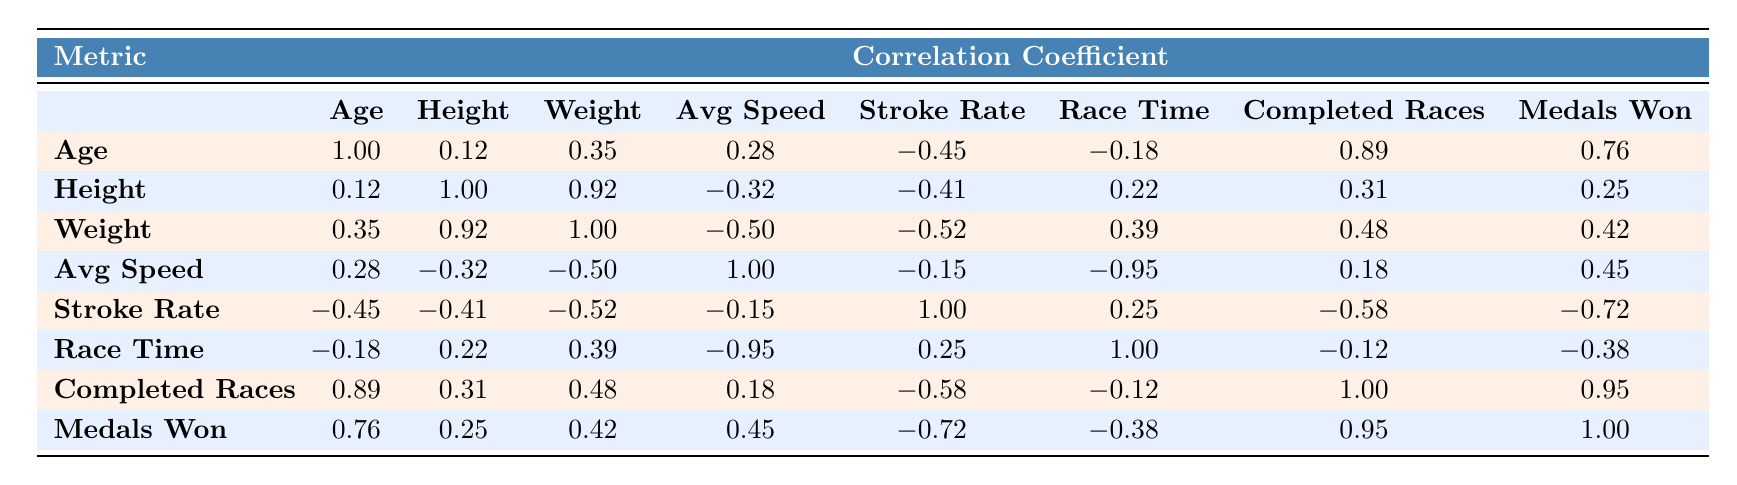What is the correlation coefficient between age and race time? According to the table, the correlation coefficient between age and race time is -0.18. This indicates a slight negative correlation, meaning as age increases, race time slightly tends to decrease.
Answer: -0.18 Which athlete has the highest average speed? By examining the Avg Speed column, Jane Smith has the highest average speed of 6.5 m/s.
Answer: 6.5 m/s Is there a strong correlation between completed races and medals won? The table shows a correlation coefficient of 0.95 between completed races and medals won. This indicates a very strong positive correlation, meaning as the number of completed races increases, the number of medals won also tends to increase significantly.
Answer: Yes What is the average stroke rate of the athletes listed? To find the average stroke rate, sum the stroke rates (32 + 30 + 34 + 31 + 33 = 160) and divide by the number of athletes (5). Thus, the average stroke rate is 160 / 5 = 32.
Answer: 32 If we compare the height of Michael Brown and Emily Wilson, who is taller and by how many centimeters? Michael Brown's height is 190 cm while Emily Wilson's height is 175 cm. The difference in their heights is 190 - 175 = 15 cm, indicating Michael is taller by 15 cm.
Answer: 15 cm What is the relationship between weight and average speed? The correlation coefficient between weight and average speed is -0.50, indicating a moderate negative relationship; as weight increases, the average speed tends to decrease.
Answer: Moderate negative correlation How many athletes have completed more than 12 races? By looking at the Completed Races column, John Doe (12), Jane Smith (15), Michael Brown (14), and Emily Wilson (13) have completed more than 12 races, totaling 4 athletes.
Answer: 4 athletes What is the medal count for the youngest athlete? The youngest athlete is Emily Wilson at 22 years of age, and she has won 4 medals.
Answer: 4 medals What is the median race time of the athletes? The race times are 300, 295, 310, 305, and 292 seconds. First, arrange them in order: 292, 295, 300, 305, 310. The median is the middle value, which is 300 seconds.
Answer: 300 seconds 